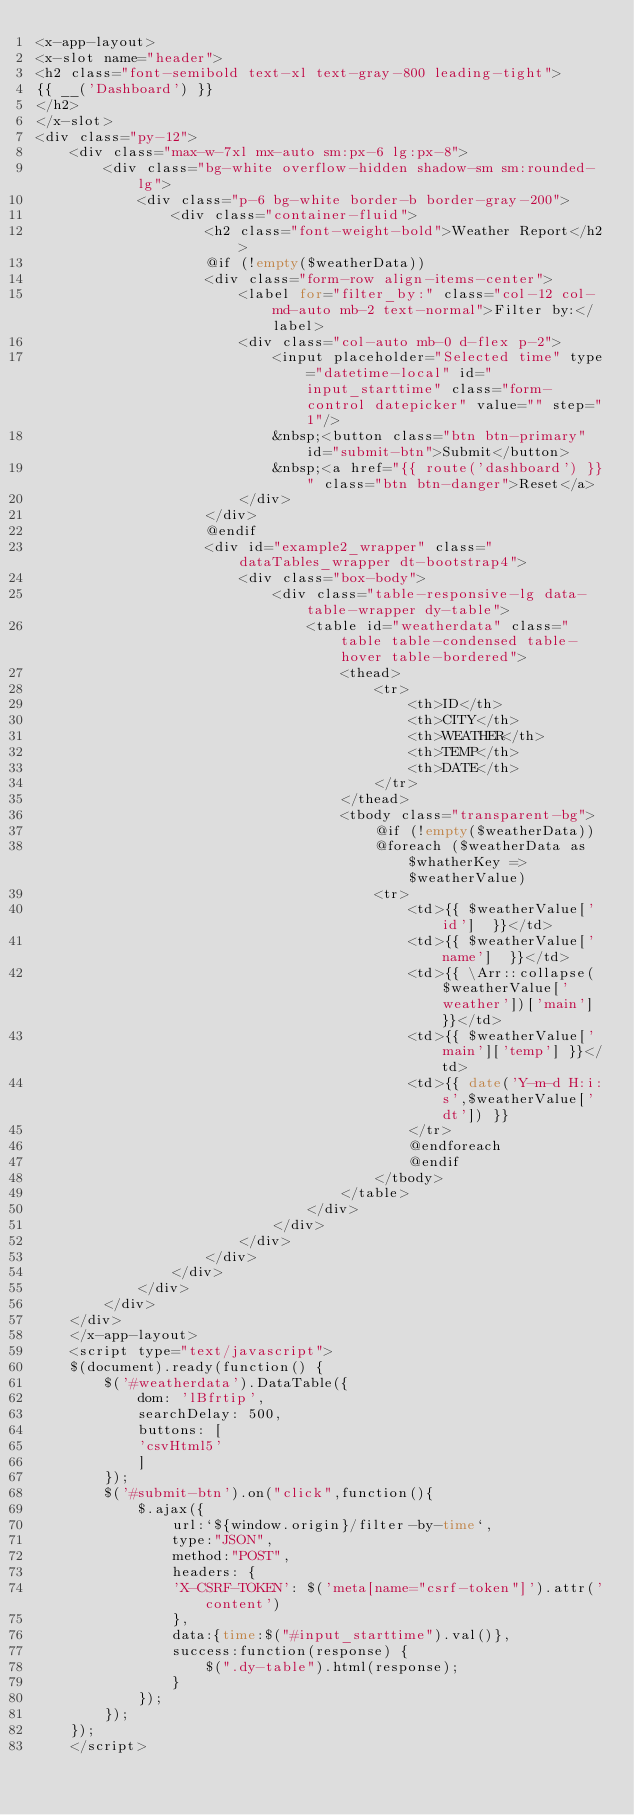<code> <loc_0><loc_0><loc_500><loc_500><_PHP_><x-app-layout>
<x-slot name="header">
<h2 class="font-semibold text-xl text-gray-800 leading-tight">
{{ __('Dashboard') }}
</h2>
</x-slot>
<div class="py-12">
    <div class="max-w-7xl mx-auto sm:px-6 lg:px-8">
        <div class="bg-white overflow-hidden shadow-sm sm:rounded-lg">
            <div class="p-6 bg-white border-b border-gray-200">
                <div class="container-fluid">
                    <h2 class="font-weight-bold">Weather Report</h2>
                    @if (!empty($weatherData))
                    <div class="form-row align-items-center">
                        <label for="filter_by:" class="col-12 col-md-auto mb-2 text-normal">Filter by:</label>
                        <div class="col-auto mb-0 d-flex p-2">
                            <input placeholder="Selected time" type="datetime-local" id="input_starttime" class="form-control datepicker" value="" step="1"/>
                            &nbsp;<button class="btn btn-primary" id="submit-btn">Submit</button>
                            &nbsp;<a href="{{ route('dashboard') }}" class="btn btn-danger">Reset</a>
                        </div>
                    </div>
                    @endif
                    <div id="example2_wrapper" class="dataTables_wrapper dt-bootstrap4">
                        <div class="box-body">
                            <div class="table-responsive-lg data-table-wrapper dy-table">
                                <table id="weatherdata" class="table table-condensed table-hover table-bordered">
                                    <thead>
                                        <tr>
                                            <th>ID</th>
                                            <th>CITY</th>
                                            <th>WEATHER</th>
                                            <th>TEMP</th>
                                            <th>DATE</th>
                                        </tr>
                                    </thead>
                                    <tbody class="transparent-bg">
                                        @if (!empty($weatherData))
                                        @foreach ($weatherData as $whatherKey => $weatherValue)
                                        <tr>
                                            <td>{{ $weatherValue['id']  }}</td>
                                            <td>{{ $weatherValue['name']  }}</td>
                                            <td>{{ \Arr::collapse($weatherValue['weather'])['main'] }}</td>
                                            <td>{{ $weatherValue['main']['temp'] }}</td>
                                            <td>{{ date('Y-m-d H:i:s',$weatherValue['dt']) }}
                                            </tr>
                                            @endforeach
                                            @endif
                                        </tbody>
                                    </table>
                                </div>
                            </div>
                        </div>
                    </div>
                </div>
            </div>
        </div>
    </div>
    </x-app-layout>
    <script type="text/javascript">
    $(document).ready(function() {
        $('#weatherdata').DataTable({
            dom: 'lBfrtip',
            searchDelay: 500,
            buttons: [
            'csvHtml5'
            ]
        });
        $('#submit-btn').on("click",function(){
            $.ajax({
                url:`${window.origin}/filter-by-time`,
                type:"JSON",
                method:"POST",
                headers: {
                'X-CSRF-TOKEN': $('meta[name="csrf-token"]').attr('content')
                },
                data:{time:$("#input_starttime").val()},
                success:function(response) {
                    $(".dy-table").html(response);
                }
            });
        });
    });
    </script></code> 